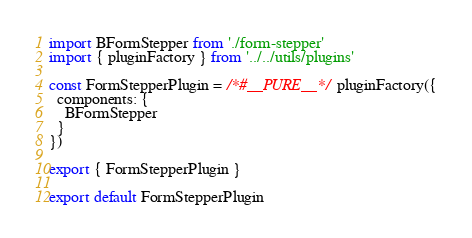Convert code to text. <code><loc_0><loc_0><loc_500><loc_500><_JavaScript_>import BFormStepper from './form-stepper'
import { pluginFactory } from '../../utils/plugins'

const FormStepperPlugin = /*#__PURE__*/ pluginFactory({
  components: {
    BFormStepper
  }
})

export { FormStepperPlugin }

export default FormStepperPlugin
</code> 